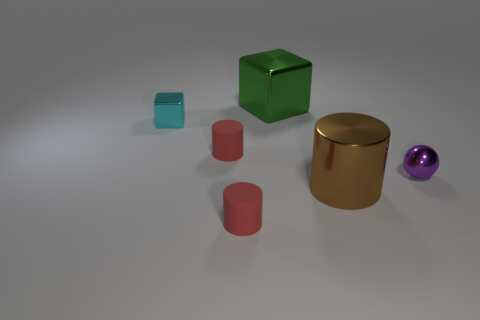Do the cyan cube behind the tiny purple shiny sphere and the red object in front of the shiny sphere have the same material?
Your response must be concise. No. How many objects are either red shiny cubes or big shiny objects that are behind the small cyan metal thing?
Your response must be concise. 1. What is the material of the green cube?
Provide a succinct answer. Metal. Do the large brown object and the green cube have the same material?
Your answer should be very brief. Yes. How many metallic things are either large cyan cylinders or large brown cylinders?
Keep it short and to the point. 1. There is a tiny metal thing that is behind the purple ball; what shape is it?
Provide a succinct answer. Cube. There is a cyan cube that is the same material as the ball; what is its size?
Offer a very short reply. Small. There is a shiny object that is on the left side of the brown cylinder and in front of the large green object; what is its shape?
Make the answer very short. Cube. There is a tiny red matte object that is in front of the purple sphere; does it have the same shape as the tiny red rubber object that is behind the brown cylinder?
Ensure brevity in your answer.  Yes. What size is the red object that is behind the purple metallic thing?
Provide a short and direct response. Small. 